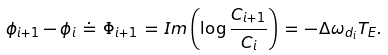Convert formula to latex. <formula><loc_0><loc_0><loc_500><loc_500>\phi _ { i + 1 } - \phi _ { i } \, \doteq \, \Phi _ { i + 1 } \, = \, I m \left ( \log { \frac { C _ { i + 1 } } { C _ { i } } } \right ) \, = \, - \Delta \omega _ { d _ { i } } T _ { E } .</formula> 